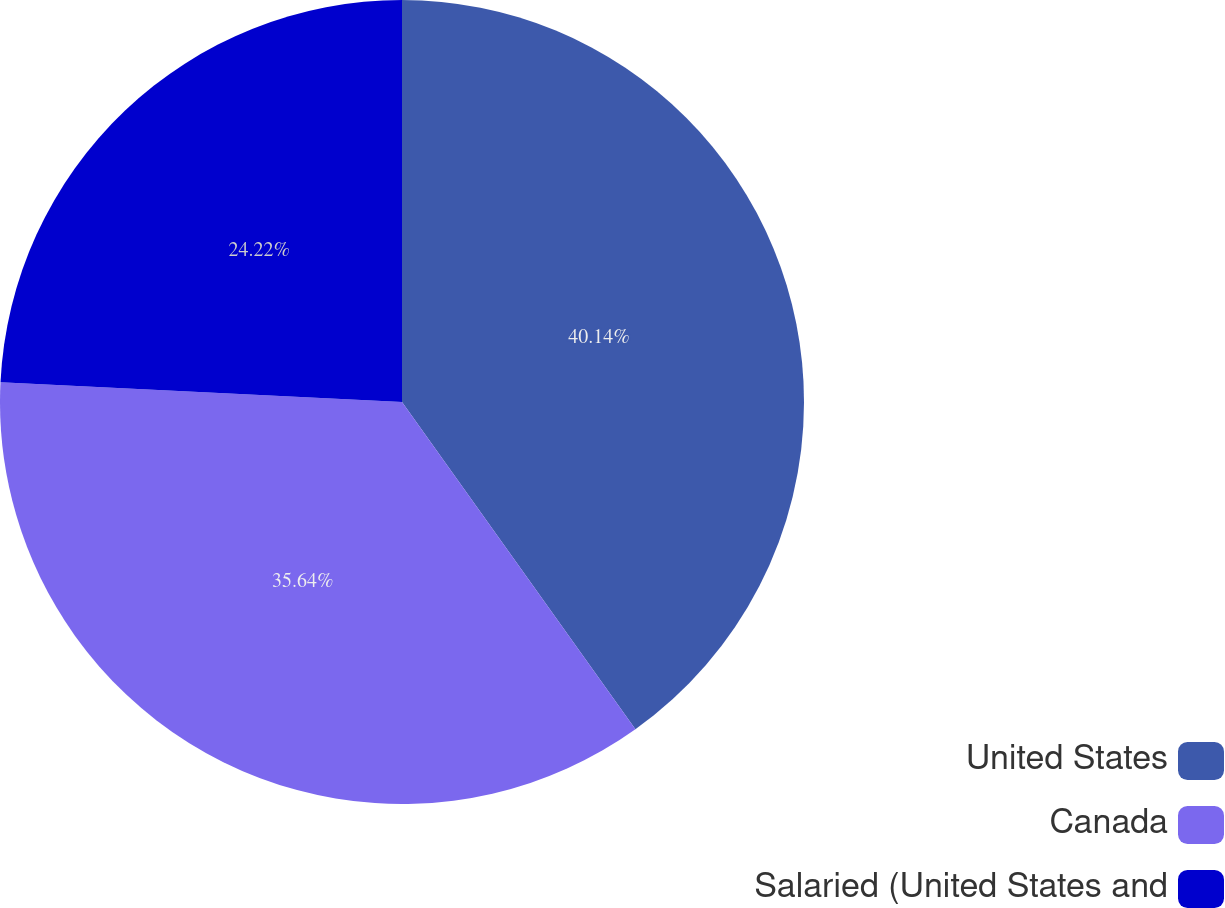<chart> <loc_0><loc_0><loc_500><loc_500><pie_chart><fcel>United States<fcel>Canada<fcel>Salaried (United States and<nl><fcel>40.14%<fcel>35.64%<fcel>24.22%<nl></chart> 